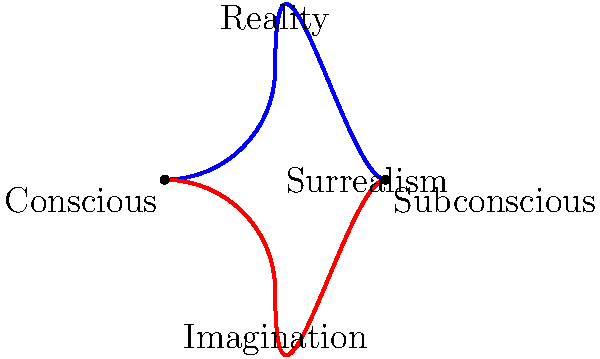In Salvador Dalí's paintings, melting clocks often symbolize the fluidity of time. How might this visual metaphor be represented in the diagram, and what does it reveal about the nature of surrealist art? 1. The diagram shows two curved paths intersecting at two points, representing the relationship between reality and imagination in surrealist art.

2. The blue curve, labeled "Reality," represents our conscious perception of the world.

3. The red curve, labeled "Imagination," represents our subconscious mind and dream-like states.

4. The intersection points, labeled "Conscious" and "Subconscious," show where these realms meet in surrealist art.

5. Dalí's melting clocks could be visualized as objects transitioning along these curves, blending reality and imagination.

6. The fluidity of the curves mirrors the fluidity of time in Dalí's paintings, showing how surrealism distorts familiar objects and concepts.

7. The label "Surrealism" at the center suggests that surrealist art exists in the space between reality and imagination, conscious and subconscious.

8. This representation reveals that surrealist art, like Dalí's melting clocks, aims to bridge the gap between the tangible world and the realm of dreams and subconscious thought.

9. The visual metaphor of melting clocks, when considered in this context, becomes a powerful tool for exploring the malleable nature of perception and time in surrealist art.
Answer: The melting clocks symbolize the fluid intersection of reality and imagination, revealing surrealism's exploration of the conscious and subconscious realms. 